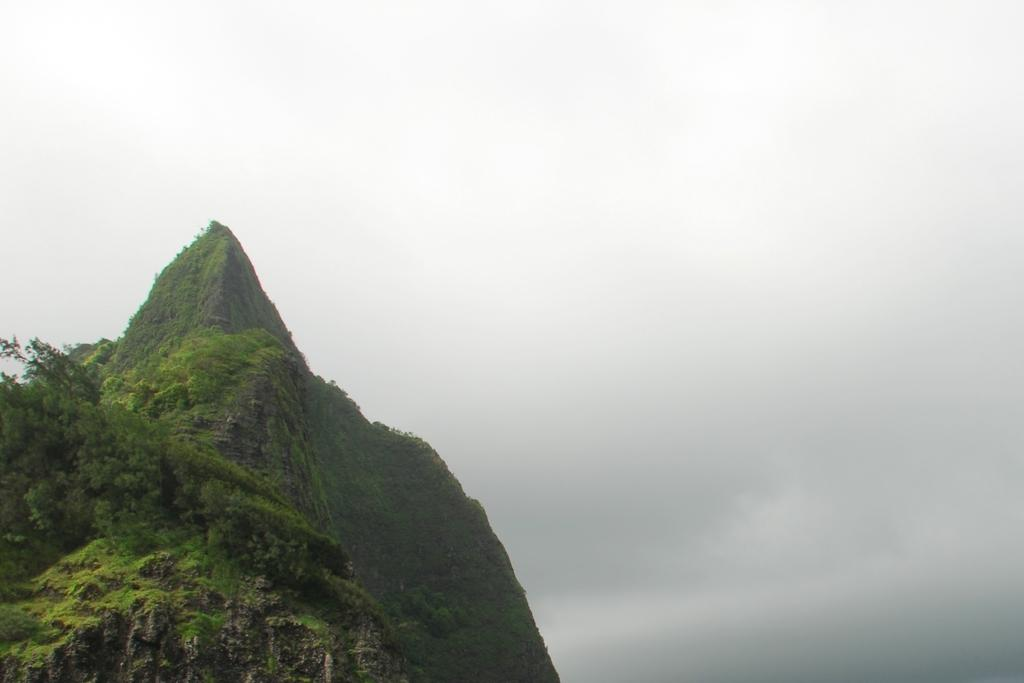What type of landform is present in the image? There is a hill in the image. What else can be seen in the image besides the hill? There are plants in the image. What is visible in the background of the image? The sky is visible in the background of the image. What type of glue is being used to hold the hill together in the image? There is no glue present in the image; it is a natural hill. What is the limit of the plants in the image? The question is unclear, but there is no mention of a limit for the plants in the image. 